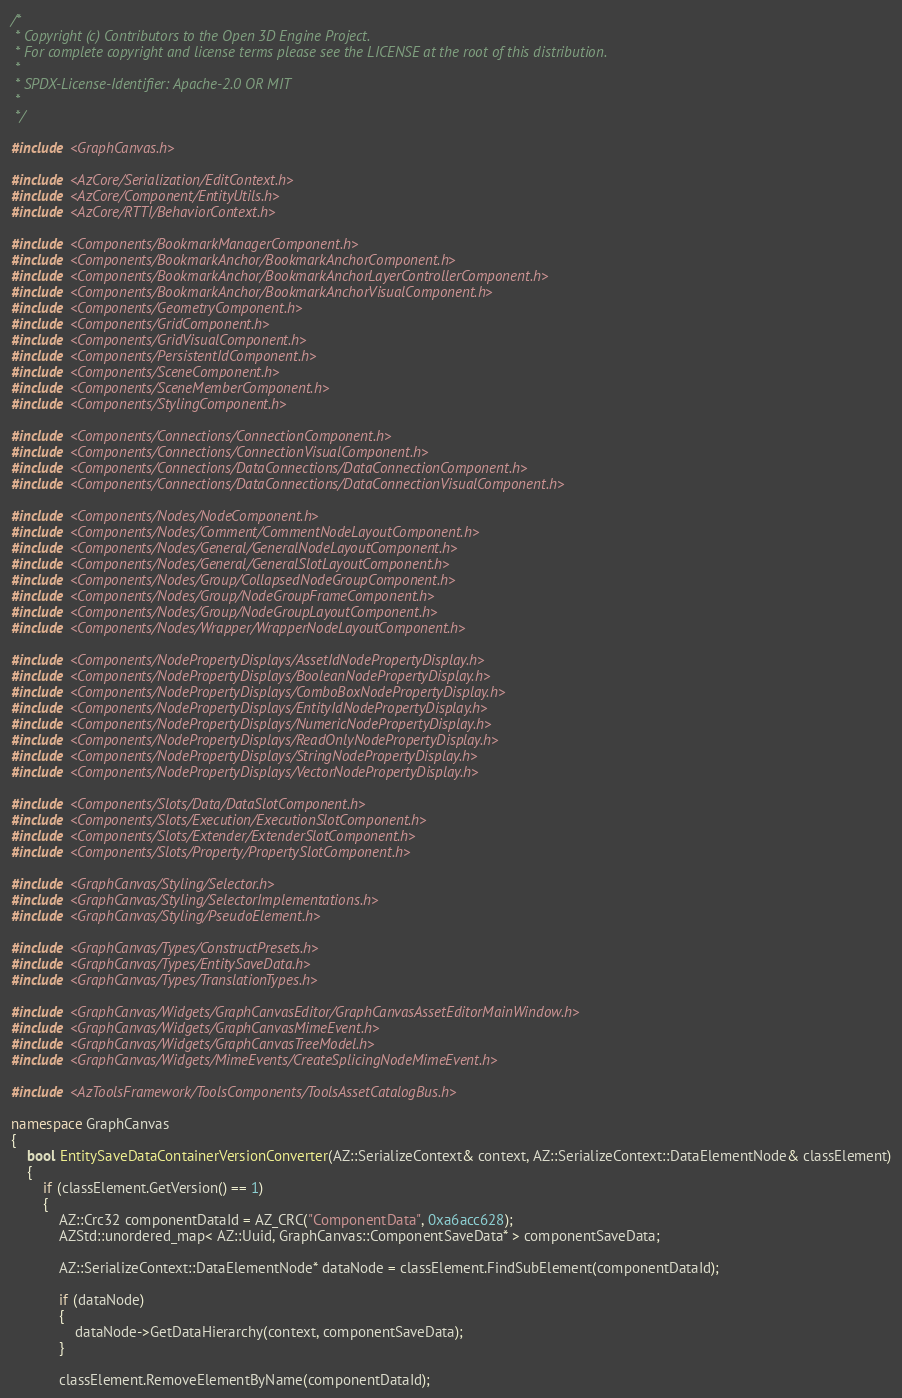Convert code to text. <code><loc_0><loc_0><loc_500><loc_500><_C++_>/*
 * Copyright (c) Contributors to the Open 3D Engine Project.
 * For complete copyright and license terms please see the LICENSE at the root of this distribution.
 *
 * SPDX-License-Identifier: Apache-2.0 OR MIT
 *
 */

#include <GraphCanvas.h>

#include <AzCore/Serialization/EditContext.h>
#include <AzCore/Component/EntityUtils.h>
#include <AzCore/RTTI/BehaviorContext.h>

#include <Components/BookmarkManagerComponent.h>
#include <Components/BookmarkAnchor/BookmarkAnchorComponent.h>
#include <Components/BookmarkAnchor/BookmarkAnchorLayerControllerComponent.h>
#include <Components/BookmarkAnchor/BookmarkAnchorVisualComponent.h>
#include <Components/GeometryComponent.h>
#include <Components/GridComponent.h>
#include <Components/GridVisualComponent.h>
#include <Components/PersistentIdComponent.h>
#include <Components/SceneComponent.h>
#include <Components/SceneMemberComponent.h>
#include <Components/StylingComponent.h>

#include <Components/Connections/ConnectionComponent.h>
#include <Components/Connections/ConnectionVisualComponent.h>
#include <Components/Connections/DataConnections/DataConnectionComponent.h>
#include <Components/Connections/DataConnections/DataConnectionVisualComponent.h>

#include <Components/Nodes/NodeComponent.h>
#include <Components/Nodes/Comment/CommentNodeLayoutComponent.h>
#include <Components/Nodes/General/GeneralNodeLayoutComponent.h>
#include <Components/Nodes/General/GeneralSlotLayoutComponent.h>
#include <Components/Nodes/Group/CollapsedNodeGroupComponent.h>
#include <Components/Nodes/Group/NodeGroupFrameComponent.h>
#include <Components/Nodes/Group/NodeGroupLayoutComponent.h>
#include <Components/Nodes/Wrapper/WrapperNodeLayoutComponent.h>

#include <Components/NodePropertyDisplays/AssetIdNodePropertyDisplay.h>
#include <Components/NodePropertyDisplays/BooleanNodePropertyDisplay.h>
#include <Components/NodePropertyDisplays/ComboBoxNodePropertyDisplay.h>
#include <Components/NodePropertyDisplays/EntityIdNodePropertyDisplay.h>
#include <Components/NodePropertyDisplays/NumericNodePropertyDisplay.h>
#include <Components/NodePropertyDisplays/ReadOnlyNodePropertyDisplay.h>
#include <Components/NodePropertyDisplays/StringNodePropertyDisplay.h>
#include <Components/NodePropertyDisplays/VectorNodePropertyDisplay.h>

#include <Components/Slots/Data/DataSlotComponent.h>
#include <Components/Slots/Execution/ExecutionSlotComponent.h>
#include <Components/Slots/Extender/ExtenderSlotComponent.h>
#include <Components/Slots/Property/PropertySlotComponent.h>

#include <GraphCanvas/Styling/Selector.h>
#include <GraphCanvas/Styling/SelectorImplementations.h>
#include <GraphCanvas/Styling/PseudoElement.h>

#include <GraphCanvas/Types/ConstructPresets.h>
#include <GraphCanvas/Types/EntitySaveData.h>
#include <GraphCanvas/Types/TranslationTypes.h>

#include <GraphCanvas/Widgets/GraphCanvasEditor/GraphCanvasAssetEditorMainWindow.h>
#include <GraphCanvas/Widgets/GraphCanvasMimeEvent.h>
#include <GraphCanvas/Widgets/GraphCanvasTreeModel.h>
#include <GraphCanvas/Widgets/MimeEvents/CreateSplicingNodeMimeEvent.h>

#include <AzToolsFramework/ToolsComponents/ToolsAssetCatalogBus.h>

namespace GraphCanvas
{
    bool EntitySaveDataContainerVersionConverter(AZ::SerializeContext& context, AZ::SerializeContext::DataElementNode& classElement)
    {
        if (classElement.GetVersion() == 1)
        {
            AZ::Crc32 componentDataId = AZ_CRC("ComponentData", 0xa6acc628);
            AZStd::unordered_map< AZ::Uuid, GraphCanvas::ComponentSaveData* > componentSaveData;

            AZ::SerializeContext::DataElementNode* dataNode = classElement.FindSubElement(componentDataId);

            if (dataNode)
            {
                dataNode->GetDataHierarchy(context, componentSaveData);
            }

            classElement.RemoveElementByName(componentDataId);
</code> 